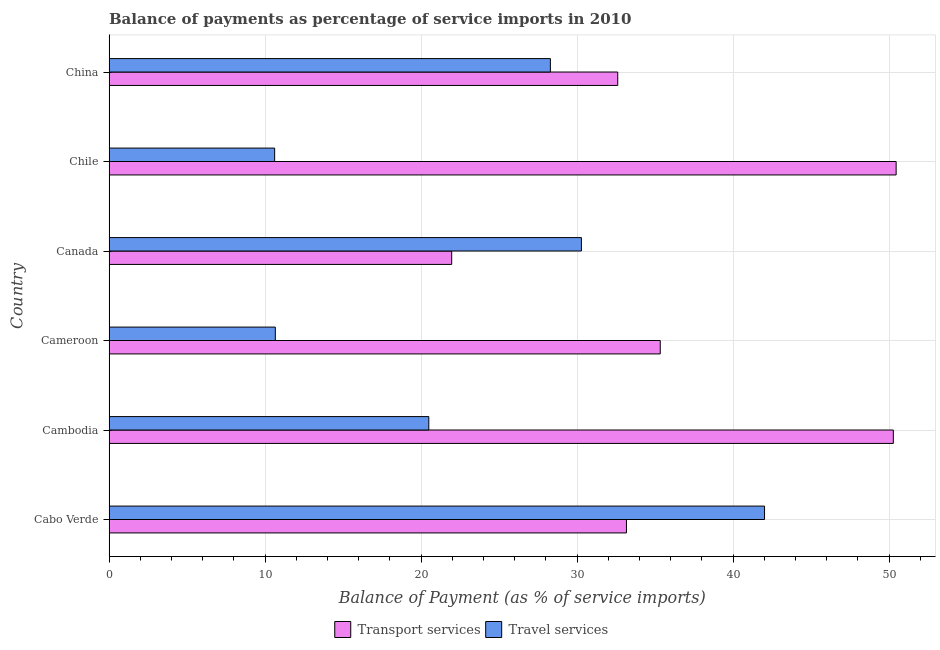How many different coloured bars are there?
Offer a very short reply. 2. Are the number of bars on each tick of the Y-axis equal?
Your answer should be compact. Yes. How many bars are there on the 1st tick from the bottom?
Make the answer very short. 2. What is the label of the 5th group of bars from the top?
Offer a terse response. Cambodia. In how many cases, is the number of bars for a given country not equal to the number of legend labels?
Offer a terse response. 0. What is the balance of payments of travel services in China?
Offer a terse response. 28.29. Across all countries, what is the maximum balance of payments of transport services?
Provide a short and direct response. 50.45. Across all countries, what is the minimum balance of payments of travel services?
Give a very brief answer. 10.61. In which country was the balance of payments of travel services maximum?
Your answer should be compact. Cabo Verde. In which country was the balance of payments of transport services minimum?
Keep it short and to the point. Canada. What is the total balance of payments of travel services in the graph?
Provide a succinct answer. 142.35. What is the difference between the balance of payments of travel services in Cambodia and that in China?
Ensure brevity in your answer.  -7.79. What is the difference between the balance of payments of travel services in China and the balance of payments of transport services in Cambodia?
Ensure brevity in your answer.  -21.98. What is the average balance of payments of travel services per country?
Keep it short and to the point. 23.73. What is the difference between the balance of payments of transport services and balance of payments of travel services in Cameroon?
Provide a succinct answer. 24.67. What is the ratio of the balance of payments of travel services in Cabo Verde to that in China?
Provide a succinct answer. 1.49. Is the difference between the balance of payments of transport services in Cameroon and Canada greater than the difference between the balance of payments of travel services in Cameroon and Canada?
Make the answer very short. Yes. What is the difference between the highest and the second highest balance of payments of transport services?
Your answer should be very brief. 0.18. What is the difference between the highest and the lowest balance of payments of transport services?
Your answer should be compact. 28.49. Is the sum of the balance of payments of travel services in Canada and Chile greater than the maximum balance of payments of transport services across all countries?
Provide a short and direct response. No. What does the 1st bar from the top in Canada represents?
Ensure brevity in your answer.  Travel services. What does the 1st bar from the bottom in Chile represents?
Provide a short and direct response. Transport services. Are all the bars in the graph horizontal?
Make the answer very short. Yes. How many countries are there in the graph?
Ensure brevity in your answer.  6. Are the values on the major ticks of X-axis written in scientific E-notation?
Give a very brief answer. No. How are the legend labels stacked?
Your answer should be compact. Horizontal. What is the title of the graph?
Offer a terse response. Balance of payments as percentage of service imports in 2010. Does "Under five" appear as one of the legend labels in the graph?
Give a very brief answer. No. What is the label or title of the X-axis?
Give a very brief answer. Balance of Payment (as % of service imports). What is the label or title of the Y-axis?
Provide a short and direct response. Country. What is the Balance of Payment (as % of service imports) of Transport services in Cabo Verde?
Offer a very short reply. 33.16. What is the Balance of Payment (as % of service imports) of Travel services in Cabo Verde?
Give a very brief answer. 42.02. What is the Balance of Payment (as % of service imports) of Transport services in Cambodia?
Give a very brief answer. 50.27. What is the Balance of Payment (as % of service imports) of Travel services in Cambodia?
Make the answer very short. 20.49. What is the Balance of Payment (as % of service imports) in Transport services in Cameroon?
Your response must be concise. 35.33. What is the Balance of Payment (as % of service imports) of Travel services in Cameroon?
Keep it short and to the point. 10.66. What is the Balance of Payment (as % of service imports) of Transport services in Canada?
Ensure brevity in your answer.  21.96. What is the Balance of Payment (as % of service imports) of Travel services in Canada?
Your answer should be very brief. 30.28. What is the Balance of Payment (as % of service imports) of Transport services in Chile?
Your answer should be compact. 50.45. What is the Balance of Payment (as % of service imports) of Travel services in Chile?
Offer a terse response. 10.61. What is the Balance of Payment (as % of service imports) of Transport services in China?
Keep it short and to the point. 32.61. What is the Balance of Payment (as % of service imports) in Travel services in China?
Your answer should be very brief. 28.29. Across all countries, what is the maximum Balance of Payment (as % of service imports) in Transport services?
Make the answer very short. 50.45. Across all countries, what is the maximum Balance of Payment (as % of service imports) in Travel services?
Keep it short and to the point. 42.02. Across all countries, what is the minimum Balance of Payment (as % of service imports) in Transport services?
Give a very brief answer. 21.96. Across all countries, what is the minimum Balance of Payment (as % of service imports) in Travel services?
Offer a very short reply. 10.61. What is the total Balance of Payment (as % of service imports) in Transport services in the graph?
Keep it short and to the point. 223.78. What is the total Balance of Payment (as % of service imports) in Travel services in the graph?
Give a very brief answer. 142.35. What is the difference between the Balance of Payment (as % of service imports) of Transport services in Cabo Verde and that in Cambodia?
Keep it short and to the point. -17.11. What is the difference between the Balance of Payment (as % of service imports) in Travel services in Cabo Verde and that in Cambodia?
Ensure brevity in your answer.  21.52. What is the difference between the Balance of Payment (as % of service imports) in Transport services in Cabo Verde and that in Cameroon?
Provide a short and direct response. -2.17. What is the difference between the Balance of Payment (as % of service imports) of Travel services in Cabo Verde and that in Cameroon?
Make the answer very short. 31.36. What is the difference between the Balance of Payment (as % of service imports) of Transport services in Cabo Verde and that in Canada?
Your answer should be compact. 11.2. What is the difference between the Balance of Payment (as % of service imports) of Travel services in Cabo Verde and that in Canada?
Your answer should be compact. 11.74. What is the difference between the Balance of Payment (as % of service imports) of Transport services in Cabo Verde and that in Chile?
Provide a short and direct response. -17.29. What is the difference between the Balance of Payment (as % of service imports) in Travel services in Cabo Verde and that in Chile?
Give a very brief answer. 31.4. What is the difference between the Balance of Payment (as % of service imports) of Transport services in Cabo Verde and that in China?
Provide a succinct answer. 0.56. What is the difference between the Balance of Payment (as % of service imports) in Travel services in Cabo Verde and that in China?
Provide a succinct answer. 13.73. What is the difference between the Balance of Payment (as % of service imports) in Transport services in Cambodia and that in Cameroon?
Provide a succinct answer. 14.94. What is the difference between the Balance of Payment (as % of service imports) in Travel services in Cambodia and that in Cameroon?
Your answer should be compact. 9.84. What is the difference between the Balance of Payment (as % of service imports) of Transport services in Cambodia and that in Canada?
Your answer should be very brief. 28.31. What is the difference between the Balance of Payment (as % of service imports) of Travel services in Cambodia and that in Canada?
Give a very brief answer. -9.78. What is the difference between the Balance of Payment (as % of service imports) in Transport services in Cambodia and that in Chile?
Offer a terse response. -0.18. What is the difference between the Balance of Payment (as % of service imports) in Travel services in Cambodia and that in Chile?
Keep it short and to the point. 9.88. What is the difference between the Balance of Payment (as % of service imports) in Transport services in Cambodia and that in China?
Provide a succinct answer. 17.67. What is the difference between the Balance of Payment (as % of service imports) of Travel services in Cambodia and that in China?
Offer a very short reply. -7.79. What is the difference between the Balance of Payment (as % of service imports) of Transport services in Cameroon and that in Canada?
Offer a terse response. 13.37. What is the difference between the Balance of Payment (as % of service imports) of Travel services in Cameroon and that in Canada?
Give a very brief answer. -19.62. What is the difference between the Balance of Payment (as % of service imports) in Transport services in Cameroon and that in Chile?
Offer a very short reply. -15.12. What is the difference between the Balance of Payment (as % of service imports) in Travel services in Cameroon and that in Chile?
Your answer should be very brief. 0.04. What is the difference between the Balance of Payment (as % of service imports) of Transport services in Cameroon and that in China?
Provide a succinct answer. 2.73. What is the difference between the Balance of Payment (as % of service imports) in Travel services in Cameroon and that in China?
Your answer should be very brief. -17.63. What is the difference between the Balance of Payment (as % of service imports) of Transport services in Canada and that in Chile?
Make the answer very short. -28.49. What is the difference between the Balance of Payment (as % of service imports) in Travel services in Canada and that in Chile?
Ensure brevity in your answer.  19.66. What is the difference between the Balance of Payment (as % of service imports) in Transport services in Canada and that in China?
Keep it short and to the point. -10.64. What is the difference between the Balance of Payment (as % of service imports) in Travel services in Canada and that in China?
Your answer should be very brief. 1.99. What is the difference between the Balance of Payment (as % of service imports) of Transport services in Chile and that in China?
Offer a terse response. 17.85. What is the difference between the Balance of Payment (as % of service imports) in Travel services in Chile and that in China?
Make the answer very short. -17.67. What is the difference between the Balance of Payment (as % of service imports) of Transport services in Cabo Verde and the Balance of Payment (as % of service imports) of Travel services in Cambodia?
Your answer should be compact. 12.67. What is the difference between the Balance of Payment (as % of service imports) in Transport services in Cabo Verde and the Balance of Payment (as % of service imports) in Travel services in Cameroon?
Keep it short and to the point. 22.51. What is the difference between the Balance of Payment (as % of service imports) in Transport services in Cabo Verde and the Balance of Payment (as % of service imports) in Travel services in Canada?
Offer a very short reply. 2.89. What is the difference between the Balance of Payment (as % of service imports) in Transport services in Cabo Verde and the Balance of Payment (as % of service imports) in Travel services in Chile?
Keep it short and to the point. 22.55. What is the difference between the Balance of Payment (as % of service imports) of Transport services in Cabo Verde and the Balance of Payment (as % of service imports) of Travel services in China?
Your answer should be compact. 4.88. What is the difference between the Balance of Payment (as % of service imports) of Transport services in Cambodia and the Balance of Payment (as % of service imports) of Travel services in Cameroon?
Offer a very short reply. 39.61. What is the difference between the Balance of Payment (as % of service imports) of Transport services in Cambodia and the Balance of Payment (as % of service imports) of Travel services in Canada?
Your answer should be compact. 19.99. What is the difference between the Balance of Payment (as % of service imports) of Transport services in Cambodia and the Balance of Payment (as % of service imports) of Travel services in Chile?
Keep it short and to the point. 39.66. What is the difference between the Balance of Payment (as % of service imports) of Transport services in Cambodia and the Balance of Payment (as % of service imports) of Travel services in China?
Offer a very short reply. 21.98. What is the difference between the Balance of Payment (as % of service imports) of Transport services in Cameroon and the Balance of Payment (as % of service imports) of Travel services in Canada?
Your response must be concise. 5.05. What is the difference between the Balance of Payment (as % of service imports) in Transport services in Cameroon and the Balance of Payment (as % of service imports) in Travel services in Chile?
Your answer should be compact. 24.72. What is the difference between the Balance of Payment (as % of service imports) in Transport services in Cameroon and the Balance of Payment (as % of service imports) in Travel services in China?
Ensure brevity in your answer.  7.04. What is the difference between the Balance of Payment (as % of service imports) of Transport services in Canada and the Balance of Payment (as % of service imports) of Travel services in Chile?
Provide a succinct answer. 11.35. What is the difference between the Balance of Payment (as % of service imports) in Transport services in Canada and the Balance of Payment (as % of service imports) in Travel services in China?
Your answer should be very brief. -6.33. What is the difference between the Balance of Payment (as % of service imports) of Transport services in Chile and the Balance of Payment (as % of service imports) of Travel services in China?
Provide a short and direct response. 22.16. What is the average Balance of Payment (as % of service imports) in Transport services per country?
Keep it short and to the point. 37.3. What is the average Balance of Payment (as % of service imports) of Travel services per country?
Make the answer very short. 23.72. What is the difference between the Balance of Payment (as % of service imports) in Transport services and Balance of Payment (as % of service imports) in Travel services in Cabo Verde?
Make the answer very short. -8.85. What is the difference between the Balance of Payment (as % of service imports) of Transport services and Balance of Payment (as % of service imports) of Travel services in Cambodia?
Your response must be concise. 29.78. What is the difference between the Balance of Payment (as % of service imports) in Transport services and Balance of Payment (as % of service imports) in Travel services in Cameroon?
Your answer should be very brief. 24.67. What is the difference between the Balance of Payment (as % of service imports) of Transport services and Balance of Payment (as % of service imports) of Travel services in Canada?
Your answer should be compact. -8.31. What is the difference between the Balance of Payment (as % of service imports) of Transport services and Balance of Payment (as % of service imports) of Travel services in Chile?
Provide a short and direct response. 39.84. What is the difference between the Balance of Payment (as % of service imports) of Transport services and Balance of Payment (as % of service imports) of Travel services in China?
Offer a very short reply. 4.32. What is the ratio of the Balance of Payment (as % of service imports) of Transport services in Cabo Verde to that in Cambodia?
Your answer should be very brief. 0.66. What is the ratio of the Balance of Payment (as % of service imports) of Travel services in Cabo Verde to that in Cambodia?
Your answer should be compact. 2.05. What is the ratio of the Balance of Payment (as % of service imports) of Transport services in Cabo Verde to that in Cameroon?
Your answer should be compact. 0.94. What is the ratio of the Balance of Payment (as % of service imports) in Travel services in Cabo Verde to that in Cameroon?
Give a very brief answer. 3.94. What is the ratio of the Balance of Payment (as % of service imports) of Transport services in Cabo Verde to that in Canada?
Offer a terse response. 1.51. What is the ratio of the Balance of Payment (as % of service imports) of Travel services in Cabo Verde to that in Canada?
Give a very brief answer. 1.39. What is the ratio of the Balance of Payment (as % of service imports) in Transport services in Cabo Verde to that in Chile?
Offer a terse response. 0.66. What is the ratio of the Balance of Payment (as % of service imports) of Travel services in Cabo Verde to that in Chile?
Ensure brevity in your answer.  3.96. What is the ratio of the Balance of Payment (as % of service imports) in Transport services in Cabo Verde to that in China?
Give a very brief answer. 1.02. What is the ratio of the Balance of Payment (as % of service imports) in Travel services in Cabo Verde to that in China?
Your answer should be compact. 1.49. What is the ratio of the Balance of Payment (as % of service imports) of Transport services in Cambodia to that in Cameroon?
Give a very brief answer. 1.42. What is the ratio of the Balance of Payment (as % of service imports) of Travel services in Cambodia to that in Cameroon?
Provide a succinct answer. 1.92. What is the ratio of the Balance of Payment (as % of service imports) of Transport services in Cambodia to that in Canada?
Your answer should be compact. 2.29. What is the ratio of the Balance of Payment (as % of service imports) of Travel services in Cambodia to that in Canada?
Your response must be concise. 0.68. What is the ratio of the Balance of Payment (as % of service imports) in Travel services in Cambodia to that in Chile?
Your answer should be very brief. 1.93. What is the ratio of the Balance of Payment (as % of service imports) in Transport services in Cambodia to that in China?
Give a very brief answer. 1.54. What is the ratio of the Balance of Payment (as % of service imports) in Travel services in Cambodia to that in China?
Make the answer very short. 0.72. What is the ratio of the Balance of Payment (as % of service imports) in Transport services in Cameroon to that in Canada?
Provide a succinct answer. 1.61. What is the ratio of the Balance of Payment (as % of service imports) in Travel services in Cameroon to that in Canada?
Your answer should be very brief. 0.35. What is the ratio of the Balance of Payment (as % of service imports) of Transport services in Cameroon to that in Chile?
Offer a very short reply. 0.7. What is the ratio of the Balance of Payment (as % of service imports) of Travel services in Cameroon to that in Chile?
Provide a short and direct response. 1. What is the ratio of the Balance of Payment (as % of service imports) of Transport services in Cameroon to that in China?
Give a very brief answer. 1.08. What is the ratio of the Balance of Payment (as % of service imports) of Travel services in Cameroon to that in China?
Give a very brief answer. 0.38. What is the ratio of the Balance of Payment (as % of service imports) in Transport services in Canada to that in Chile?
Provide a succinct answer. 0.44. What is the ratio of the Balance of Payment (as % of service imports) in Travel services in Canada to that in Chile?
Provide a succinct answer. 2.85. What is the ratio of the Balance of Payment (as % of service imports) of Transport services in Canada to that in China?
Your answer should be compact. 0.67. What is the ratio of the Balance of Payment (as % of service imports) of Travel services in Canada to that in China?
Offer a terse response. 1.07. What is the ratio of the Balance of Payment (as % of service imports) in Transport services in Chile to that in China?
Your response must be concise. 1.55. What is the ratio of the Balance of Payment (as % of service imports) of Travel services in Chile to that in China?
Provide a succinct answer. 0.38. What is the difference between the highest and the second highest Balance of Payment (as % of service imports) of Transport services?
Offer a very short reply. 0.18. What is the difference between the highest and the second highest Balance of Payment (as % of service imports) in Travel services?
Your answer should be compact. 11.74. What is the difference between the highest and the lowest Balance of Payment (as % of service imports) in Transport services?
Make the answer very short. 28.49. What is the difference between the highest and the lowest Balance of Payment (as % of service imports) in Travel services?
Offer a very short reply. 31.4. 